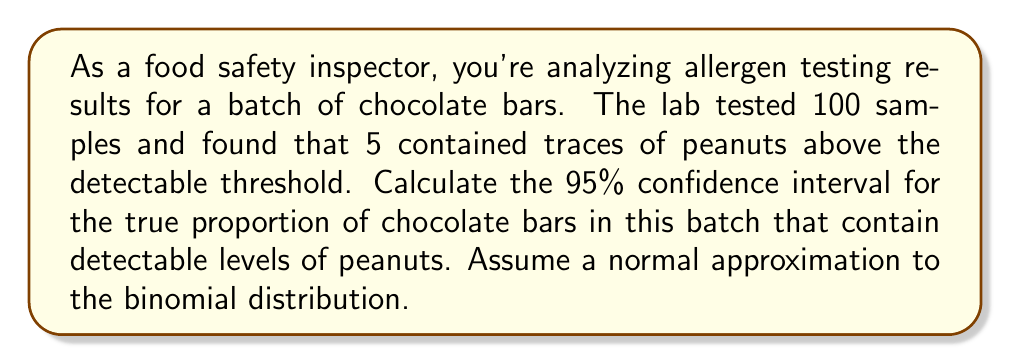Help me with this question. To calculate the confidence interval, we'll use the formula:

$$p \pm z \sqrt{\frac{p(1-p)}{n}}$$

Where:
$p$ = sample proportion
$z$ = z-score for desired confidence level (1.96 for 95% CI)
$n$ = sample size

Step 1: Calculate the sample proportion (p)
$p = \frac{\text{number of samples with peanuts}}{\text{total samples}} = \frac{5}{100} = 0.05$

Step 2: Calculate the standard error (SE)
$$SE = \sqrt{\frac{p(1-p)}{n}} = \sqrt{\frac{0.05(1-0.05)}{100}} = \sqrt{\frac{0.0475}{100}} = 0.0218$$

Step 3: Calculate the margin of error (ME)
$$ME = z \times SE = 1.96 \times 0.0218 = 0.0427$$

Step 4: Calculate the lower and upper bounds of the confidence interval
Lower bound: $0.05 - 0.0427 = 0.0073$
Upper bound: $0.05 + 0.0427 = 0.0927$

Therefore, the 95% confidence interval is (0.0073, 0.0927) or (0.73%, 9.27%).
Answer: (0.73%, 9.27%) 